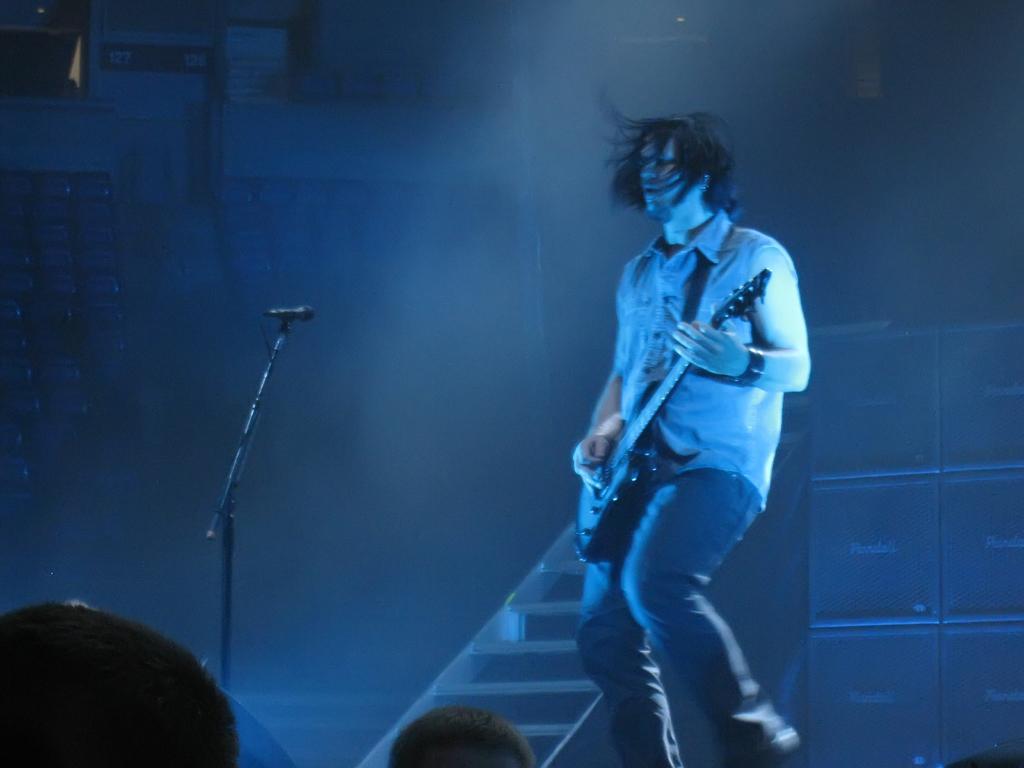How would you summarize this image in a sentence or two? In this picture there is a man walking and holding a guitar in his hand. In front of him there is a microphone and its stand. In the background there are boxes and staircase. 